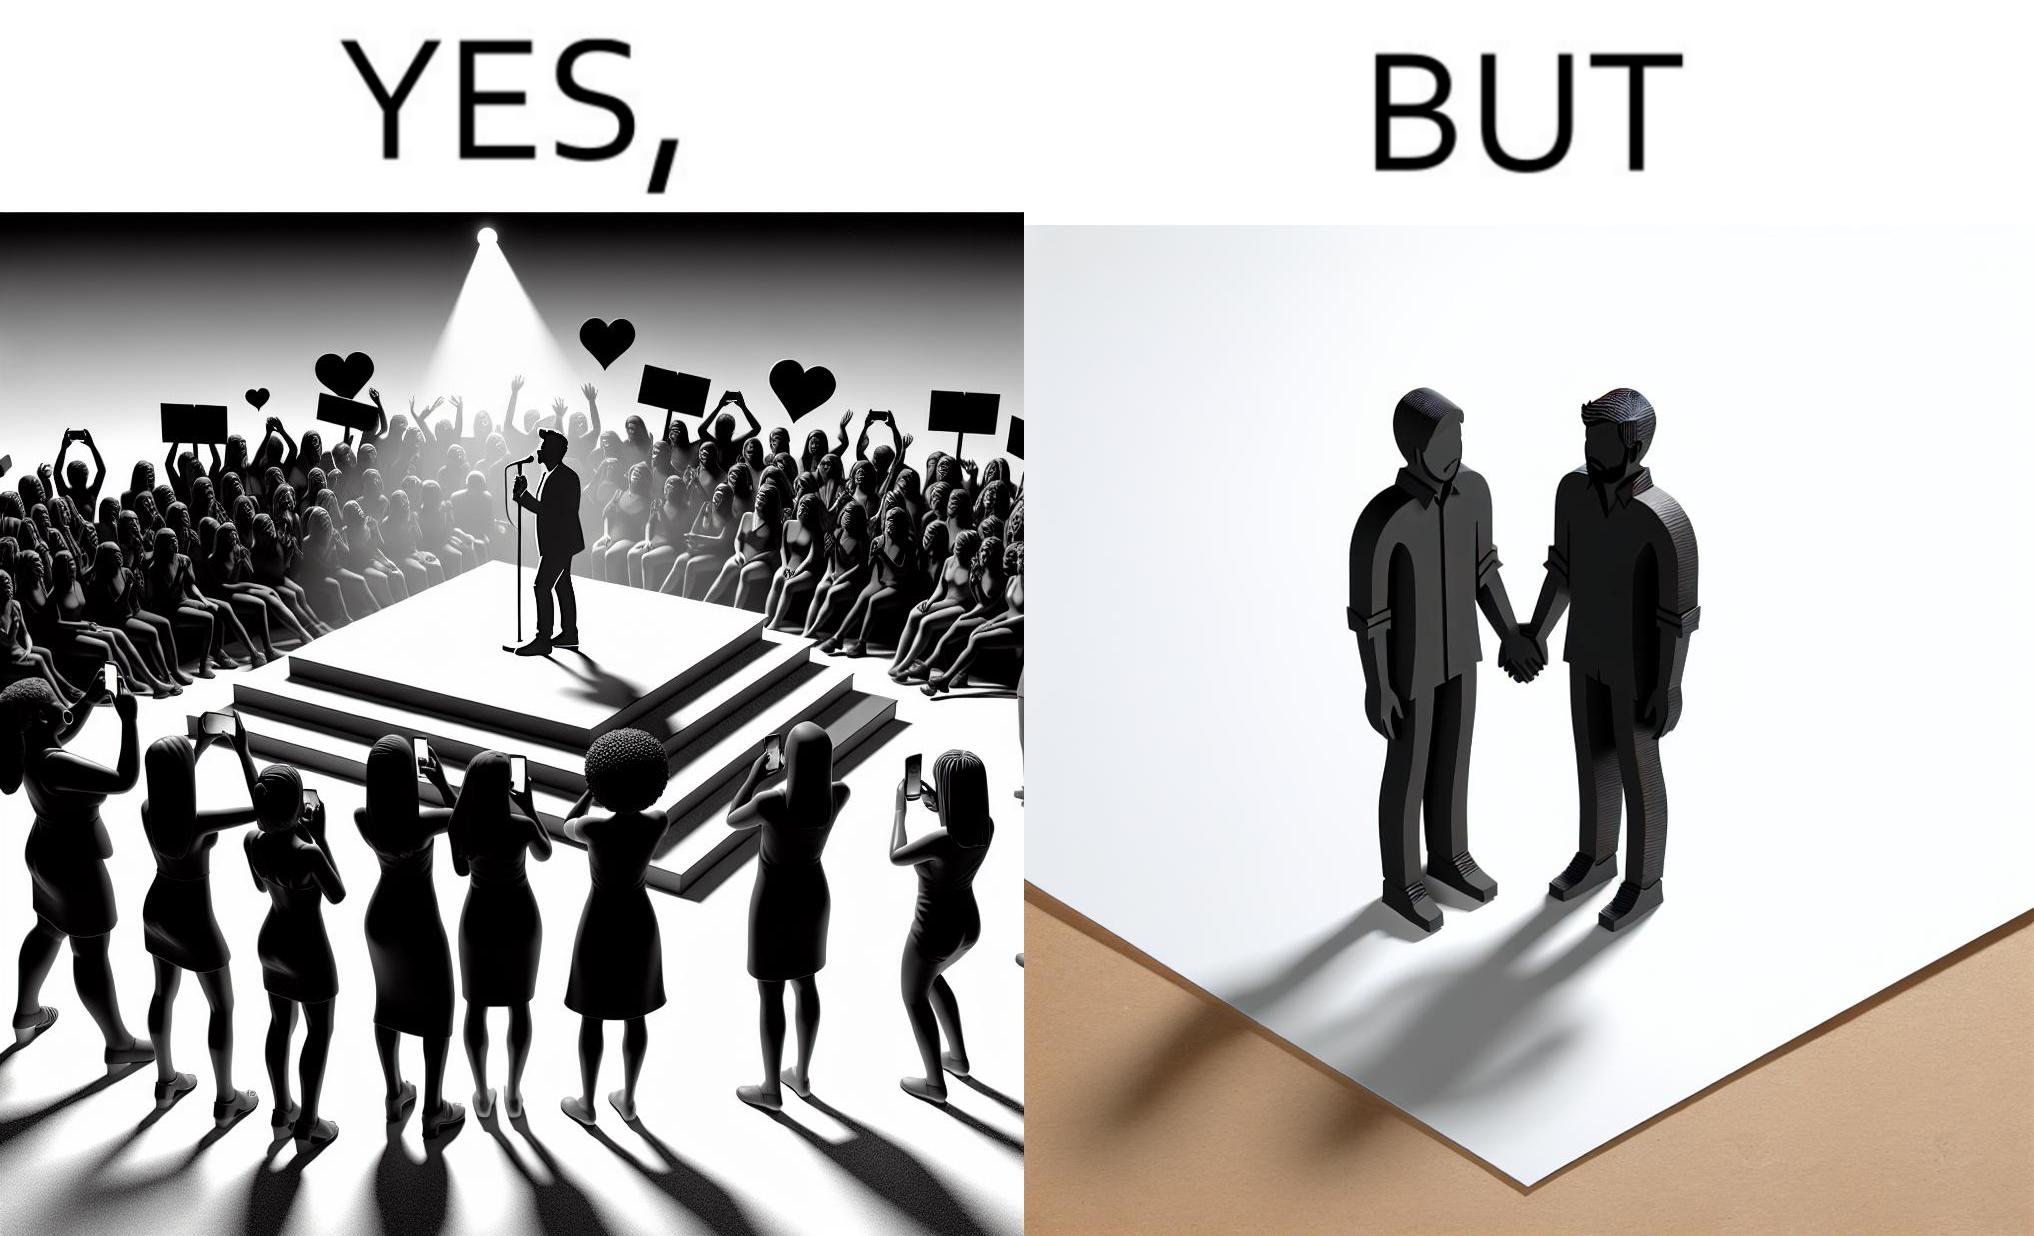Is this image satirical or non-satirical? Yes, this image is satirical. 